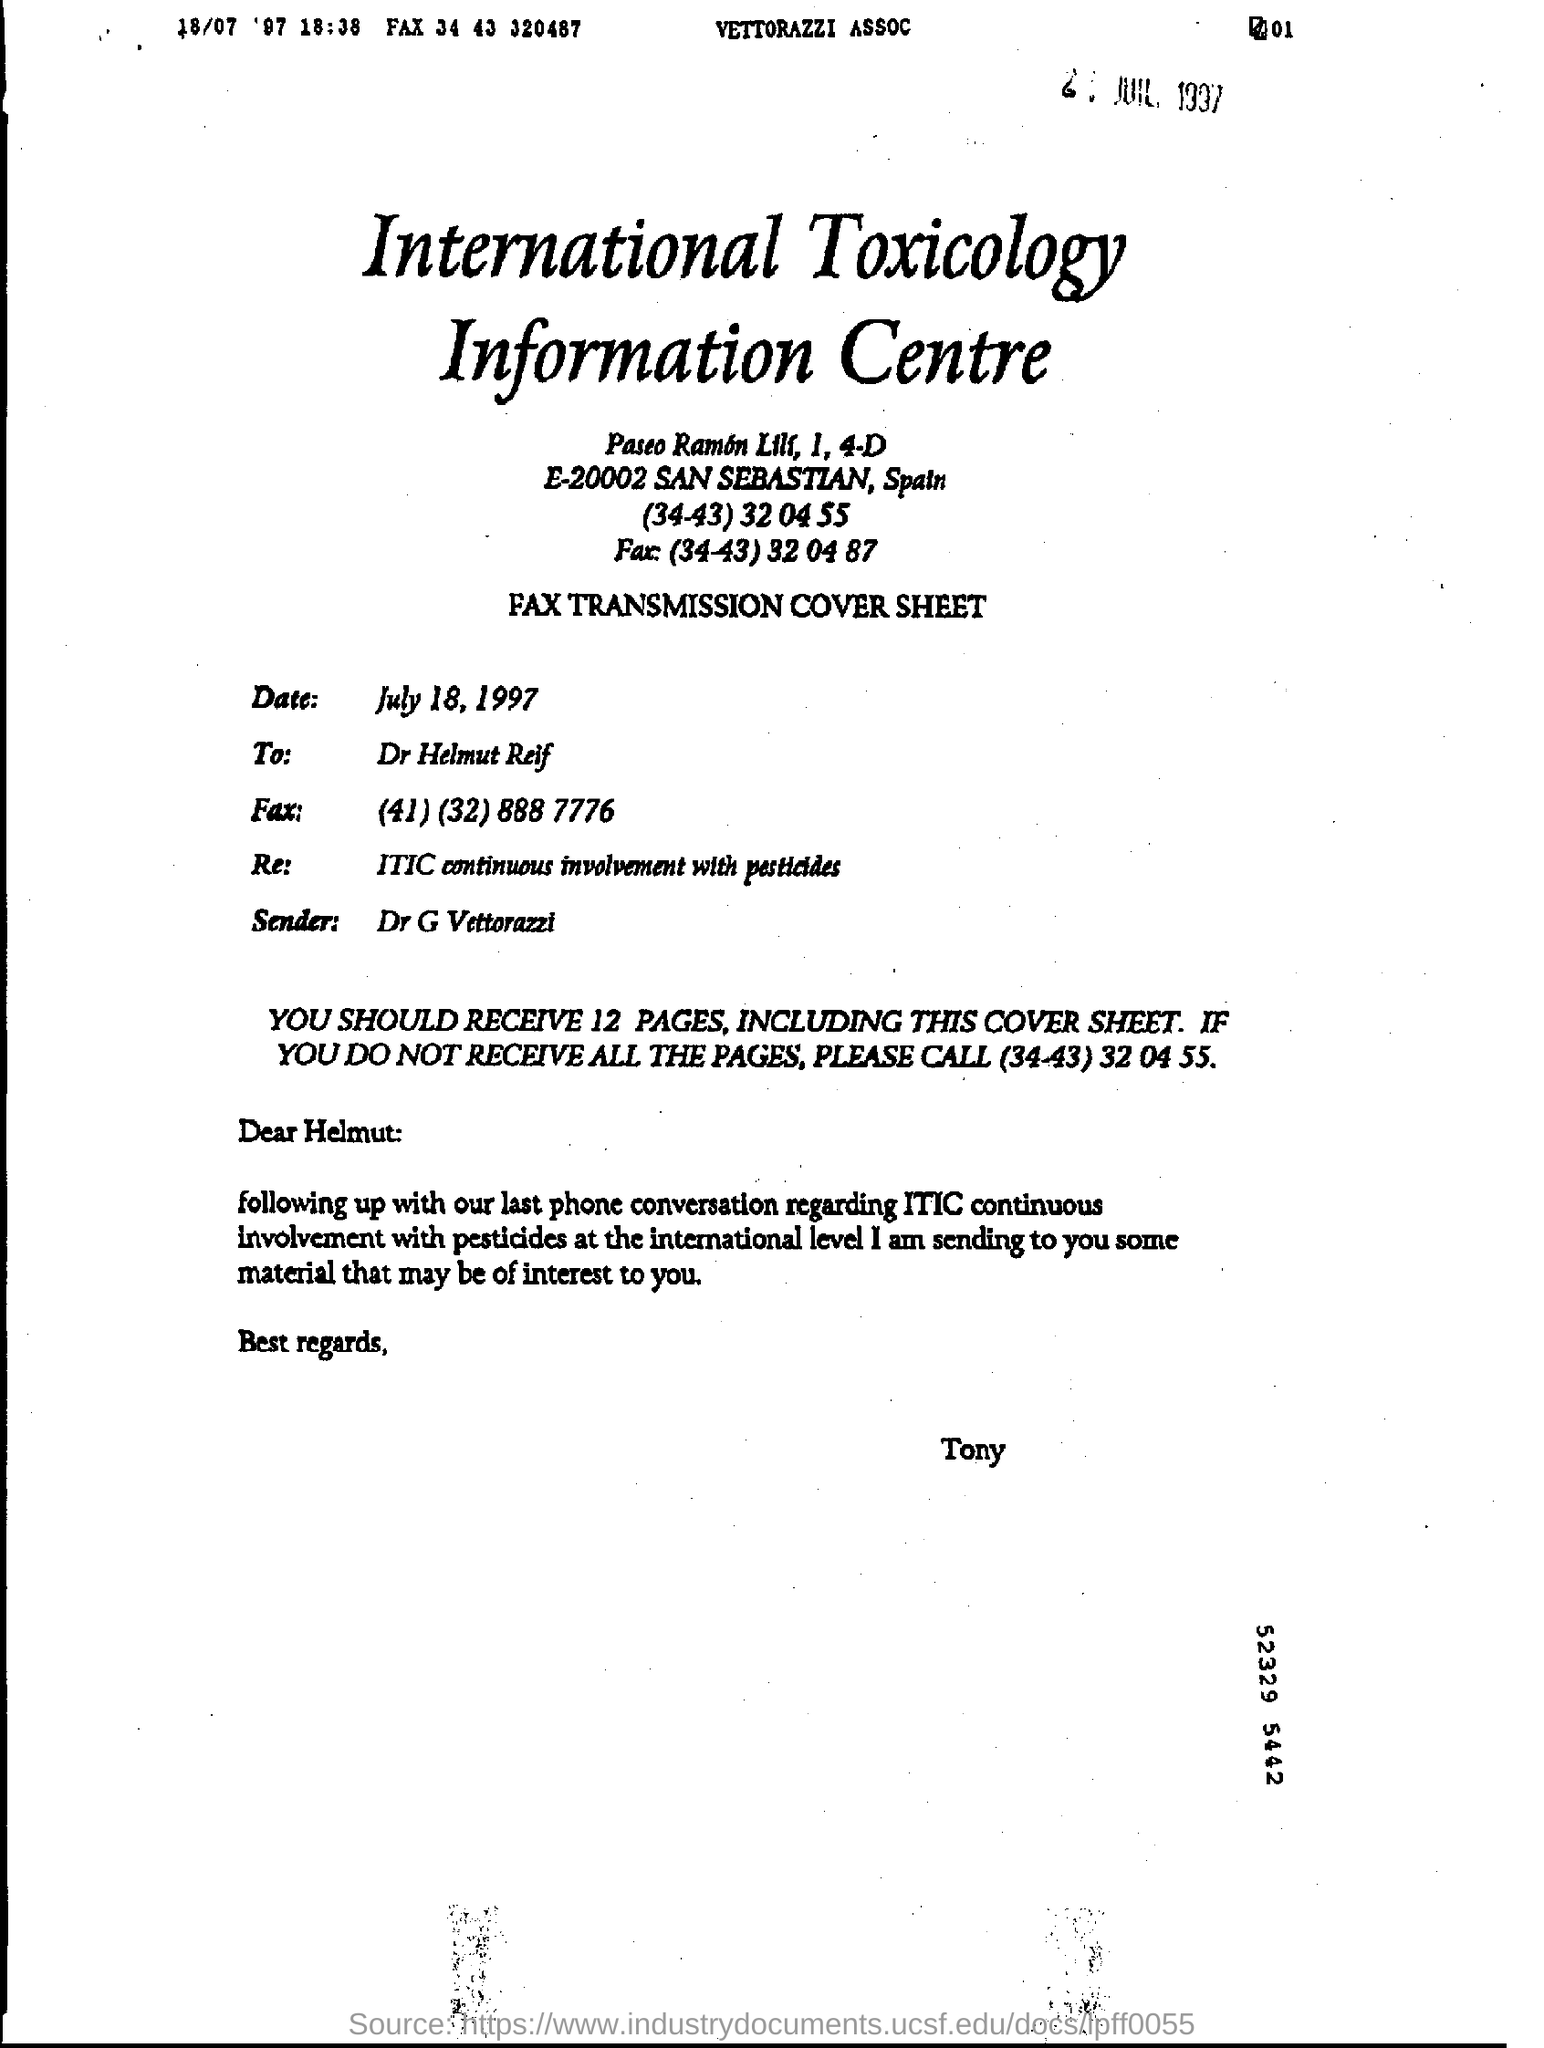Mention a couple of crucial points in this snapshot. The fax number in the To Address is (41) 32 888 7776. The International Toxicology Information Centre is the main heading of the document. The recipient of the message is Dr. Helmut Reif. The date mentioned in the document is July 18, 1997. 